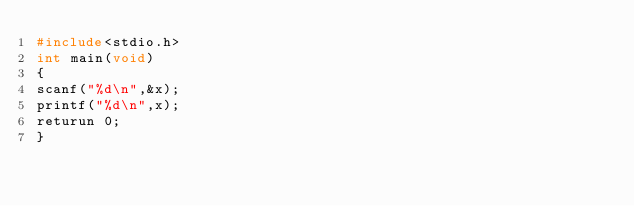<code> <loc_0><loc_0><loc_500><loc_500><_C_>#include<stdio.h>
int main(void)
{
scanf("%d\n",&x);
printf("%d\n",x);
returun 0;
}</code> 